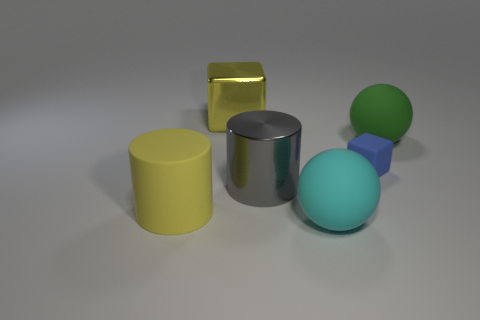How many green rubber things are the same shape as the tiny blue thing?
Give a very brief answer. 0. There is a yellow block; what number of large yellow blocks are behind it?
Offer a very short reply. 0. Do the large sphere in front of the green object and the rubber cylinder have the same color?
Offer a terse response. No. How many yellow matte cylinders have the same size as the blue matte cube?
Provide a short and direct response. 0. What is the shape of the yellow object that is the same material as the green object?
Provide a short and direct response. Cylinder. Are there any big matte objects that have the same color as the rubber block?
Your answer should be very brief. No. What is the material of the cyan sphere?
Provide a succinct answer. Rubber. What number of things are either green spheres or blue blocks?
Provide a short and direct response. 2. There is a cube that is to the right of the cyan object; what is its size?
Offer a terse response. Small. How many other objects are there of the same material as the gray cylinder?
Your answer should be compact. 1. 